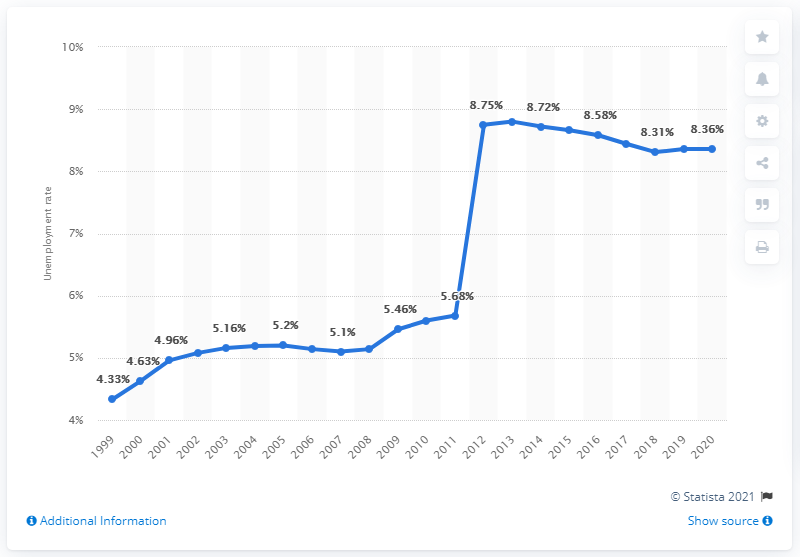Draw attention to some important aspects in this diagram. In 2020, the unemployment rate in Samoa was 8.36%. 